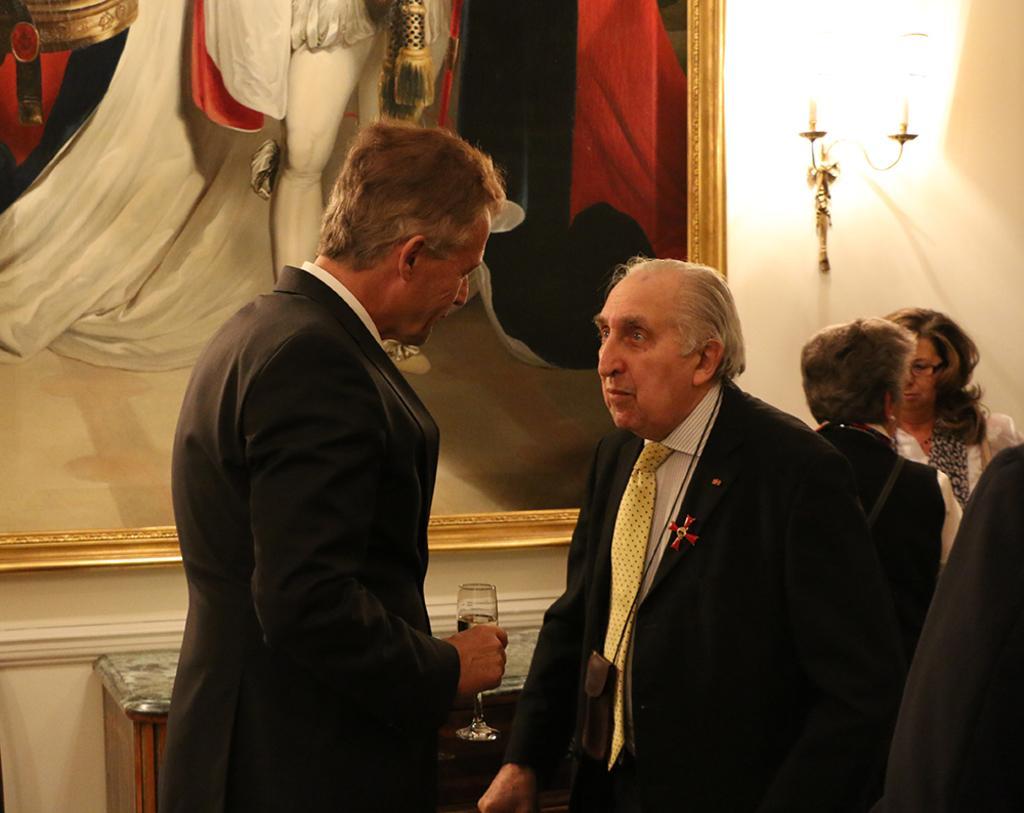Could you give a brief overview of what you see in this image? In front of the image there are two people, one of them is holding a glass of wine, behind them there are a few other people, in the background of the image there is a wooden table, in front of the table there is a photo frame and a lamp on the wall. 